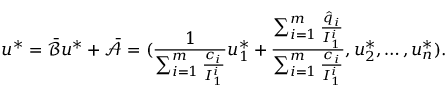Convert formula to latex. <formula><loc_0><loc_0><loc_500><loc_500>u ^ { * } = \bar { \mathcal { B } } u ^ { * } + \bar { \mathcal { A } } = ( \frac { 1 } { \sum _ { i = 1 } ^ { m } \frac { c _ { i } } { I _ { 1 } ^ { i } } } u _ { 1 } ^ { * } + \frac { \sum _ { i = 1 } ^ { m } \frac { \hat { q } _ { i } } { I _ { 1 } ^ { i } } } { \sum _ { i = 1 } ^ { m } \frac { c _ { i } } { I _ { 1 } ^ { i } } } , u _ { 2 } ^ { * } , \dots , u _ { n } ^ { * } ) .</formula> 